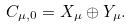Convert formula to latex. <formula><loc_0><loc_0><loc_500><loc_500>C _ { \mu , 0 } = X _ { \mu } \oplus Y _ { \mu } .</formula> 